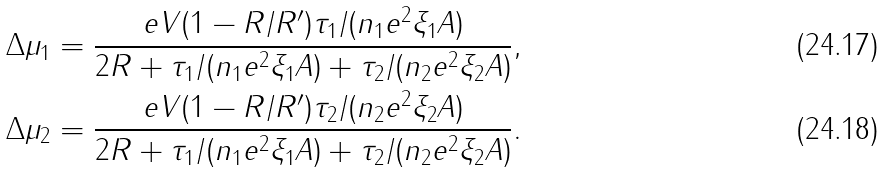<formula> <loc_0><loc_0><loc_500><loc_500>& \Delta \mu _ { 1 } = \frac { e V ( 1 - R / R ^ { \prime } ) \tau _ { 1 } / ( n _ { 1 } e ^ { 2 } \xi _ { 1 } A ) } { 2 R + \tau _ { 1 } / ( n _ { 1 } e ^ { 2 } \xi _ { 1 } A ) + \tau _ { 2 } / ( n _ { 2 } e ^ { 2 } \xi _ { 2 } A ) } , \\ & \Delta \mu _ { 2 } = \frac { e V ( 1 - R / R ^ { \prime } ) \tau _ { 2 } / ( n _ { 2 } e ^ { 2 } \xi _ { 2 } A ) } { 2 R + \tau _ { 1 } / ( n _ { 1 } e ^ { 2 } \xi _ { 1 } A ) + \tau _ { 2 } / ( n _ { 2 } e ^ { 2 } \xi _ { 2 } A ) } .</formula> 